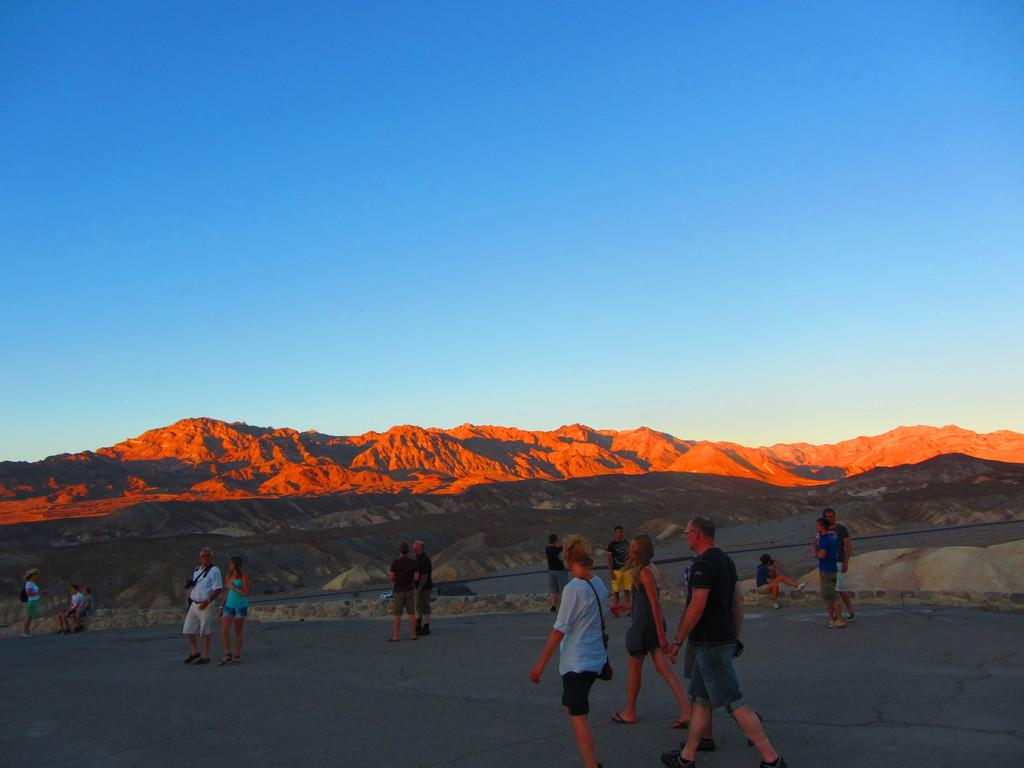How many people are in the image? There are people in the image, but the exact number is not specified. What are the people in the image doing? Some people are sitting, while others are standing. What can be seen in the background of the image? There are mountains and the sky visible in the background of the image. What type of nail is being used by the person in the image? There is no nail or person using a nail present in the image. What is the source of fear for the people in the image? There is no indication of fear or any specific source of fear for the people in the image. 